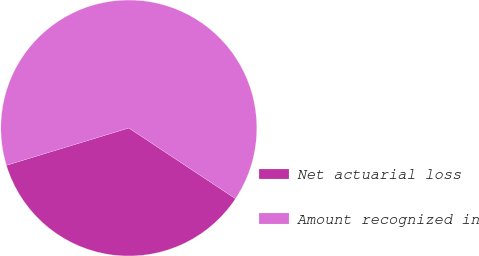Convert chart to OTSL. <chart><loc_0><loc_0><loc_500><loc_500><pie_chart><fcel>Net actuarial loss<fcel>Amount recognized in<nl><fcel>35.98%<fcel>64.02%<nl></chart> 